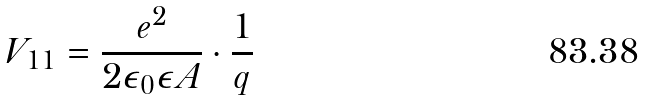Convert formula to latex. <formula><loc_0><loc_0><loc_500><loc_500>V _ { 1 1 } = \frac { e ^ { 2 } } { 2 \epsilon _ { 0 } \epsilon A } \cdot \frac { 1 } { q }</formula> 